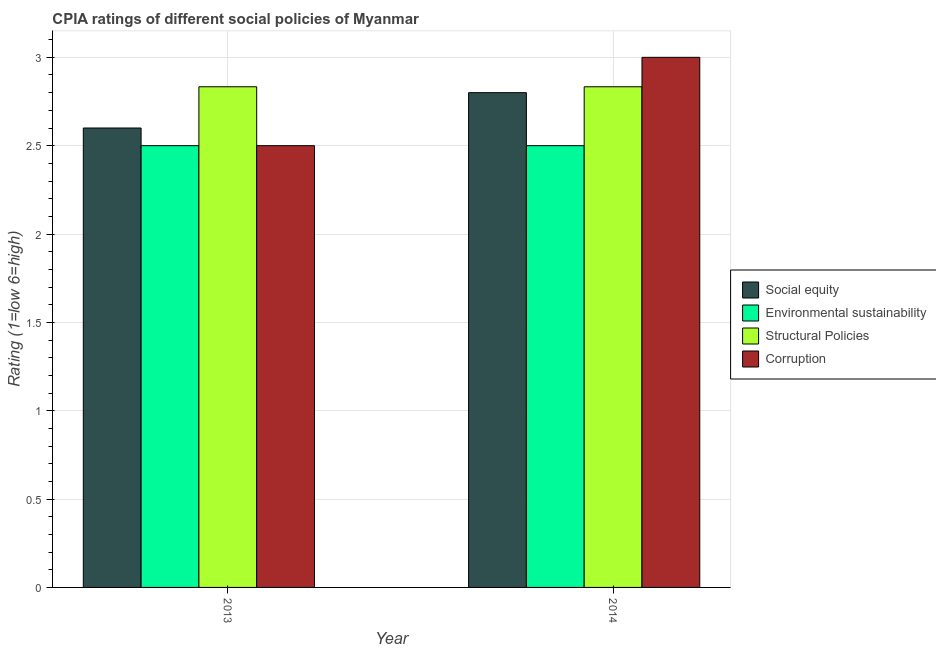Are the number of bars on each tick of the X-axis equal?
Provide a succinct answer. Yes. How many bars are there on the 2nd tick from the left?
Ensure brevity in your answer.  4. What is the label of the 1st group of bars from the left?
Offer a very short reply. 2013. In how many cases, is the number of bars for a given year not equal to the number of legend labels?
Offer a very short reply. 0. Across all years, what is the maximum cpia rating of structural policies?
Your answer should be very brief. 2.83. Across all years, what is the minimum cpia rating of structural policies?
Your answer should be very brief. 2.83. In which year was the cpia rating of corruption maximum?
Provide a succinct answer. 2014. In which year was the cpia rating of corruption minimum?
Your response must be concise. 2013. What is the total cpia rating of social equity in the graph?
Provide a succinct answer. 5.4. What is the difference between the cpia rating of social equity in 2014 and the cpia rating of corruption in 2013?
Keep it short and to the point. 0.2. In the year 2013, what is the difference between the cpia rating of environmental sustainability and cpia rating of corruption?
Offer a terse response. 0. What is the ratio of the cpia rating of structural policies in 2013 to that in 2014?
Provide a succinct answer. 1. Is the cpia rating of corruption in 2013 less than that in 2014?
Your answer should be very brief. Yes. In how many years, is the cpia rating of social equity greater than the average cpia rating of social equity taken over all years?
Give a very brief answer. 1. Is it the case that in every year, the sum of the cpia rating of corruption and cpia rating of structural policies is greater than the sum of cpia rating of social equity and cpia rating of environmental sustainability?
Give a very brief answer. No. What does the 4th bar from the left in 2013 represents?
Your answer should be very brief. Corruption. What does the 4th bar from the right in 2013 represents?
Offer a very short reply. Social equity. Is it the case that in every year, the sum of the cpia rating of social equity and cpia rating of environmental sustainability is greater than the cpia rating of structural policies?
Your answer should be very brief. Yes. How many bars are there?
Your response must be concise. 8. Are all the bars in the graph horizontal?
Provide a short and direct response. No. How many years are there in the graph?
Ensure brevity in your answer.  2. What is the difference between two consecutive major ticks on the Y-axis?
Offer a very short reply. 0.5. Does the graph contain any zero values?
Provide a succinct answer. No. How are the legend labels stacked?
Your response must be concise. Vertical. What is the title of the graph?
Make the answer very short. CPIA ratings of different social policies of Myanmar. What is the Rating (1=low 6=high) of Social equity in 2013?
Keep it short and to the point. 2.6. What is the Rating (1=low 6=high) of Structural Policies in 2013?
Provide a succinct answer. 2.83. What is the Rating (1=low 6=high) of Corruption in 2013?
Provide a short and direct response. 2.5. What is the Rating (1=low 6=high) of Social equity in 2014?
Your response must be concise. 2.8. What is the Rating (1=low 6=high) in Environmental sustainability in 2014?
Provide a succinct answer. 2.5. What is the Rating (1=low 6=high) in Structural Policies in 2014?
Your response must be concise. 2.83. Across all years, what is the maximum Rating (1=low 6=high) in Environmental sustainability?
Your answer should be very brief. 2.5. Across all years, what is the maximum Rating (1=low 6=high) of Structural Policies?
Your answer should be very brief. 2.83. Across all years, what is the minimum Rating (1=low 6=high) of Social equity?
Offer a very short reply. 2.6. Across all years, what is the minimum Rating (1=low 6=high) in Structural Policies?
Your response must be concise. 2.83. What is the total Rating (1=low 6=high) in Social equity in the graph?
Keep it short and to the point. 5.4. What is the total Rating (1=low 6=high) in Structural Policies in the graph?
Your answer should be compact. 5.67. What is the total Rating (1=low 6=high) of Corruption in the graph?
Keep it short and to the point. 5.5. What is the difference between the Rating (1=low 6=high) in Social equity in 2013 and that in 2014?
Your answer should be compact. -0.2. What is the difference between the Rating (1=low 6=high) of Structural Policies in 2013 and that in 2014?
Ensure brevity in your answer.  0. What is the difference between the Rating (1=low 6=high) of Social equity in 2013 and the Rating (1=low 6=high) of Structural Policies in 2014?
Provide a short and direct response. -0.23. What is the difference between the Rating (1=low 6=high) in Social equity in 2013 and the Rating (1=low 6=high) in Corruption in 2014?
Ensure brevity in your answer.  -0.4. What is the difference between the Rating (1=low 6=high) of Environmental sustainability in 2013 and the Rating (1=low 6=high) of Structural Policies in 2014?
Your answer should be very brief. -0.33. What is the difference between the Rating (1=low 6=high) in Structural Policies in 2013 and the Rating (1=low 6=high) in Corruption in 2014?
Provide a short and direct response. -0.17. What is the average Rating (1=low 6=high) of Social equity per year?
Provide a short and direct response. 2.7. What is the average Rating (1=low 6=high) of Environmental sustainability per year?
Offer a very short reply. 2.5. What is the average Rating (1=low 6=high) of Structural Policies per year?
Your answer should be compact. 2.83. What is the average Rating (1=low 6=high) of Corruption per year?
Offer a terse response. 2.75. In the year 2013, what is the difference between the Rating (1=low 6=high) of Social equity and Rating (1=low 6=high) of Structural Policies?
Your answer should be compact. -0.23. In the year 2013, what is the difference between the Rating (1=low 6=high) in Social equity and Rating (1=low 6=high) in Corruption?
Keep it short and to the point. 0.1. In the year 2014, what is the difference between the Rating (1=low 6=high) in Social equity and Rating (1=low 6=high) in Environmental sustainability?
Make the answer very short. 0.3. In the year 2014, what is the difference between the Rating (1=low 6=high) of Social equity and Rating (1=low 6=high) of Structural Policies?
Offer a terse response. -0.03. In the year 2014, what is the difference between the Rating (1=low 6=high) in Social equity and Rating (1=low 6=high) in Corruption?
Keep it short and to the point. -0.2. In the year 2014, what is the difference between the Rating (1=low 6=high) in Environmental sustainability and Rating (1=low 6=high) in Structural Policies?
Offer a very short reply. -0.33. In the year 2014, what is the difference between the Rating (1=low 6=high) of Structural Policies and Rating (1=low 6=high) of Corruption?
Ensure brevity in your answer.  -0.17. What is the ratio of the Rating (1=low 6=high) of Social equity in 2013 to that in 2014?
Offer a terse response. 0.93. What is the ratio of the Rating (1=low 6=high) in Structural Policies in 2013 to that in 2014?
Your answer should be compact. 1. What is the difference between the highest and the second highest Rating (1=low 6=high) of Social equity?
Ensure brevity in your answer.  0.2. What is the difference between the highest and the second highest Rating (1=low 6=high) in Structural Policies?
Offer a terse response. 0. What is the difference between the highest and the lowest Rating (1=low 6=high) of Social equity?
Ensure brevity in your answer.  0.2. What is the difference between the highest and the lowest Rating (1=low 6=high) in Environmental sustainability?
Your answer should be compact. 0. 